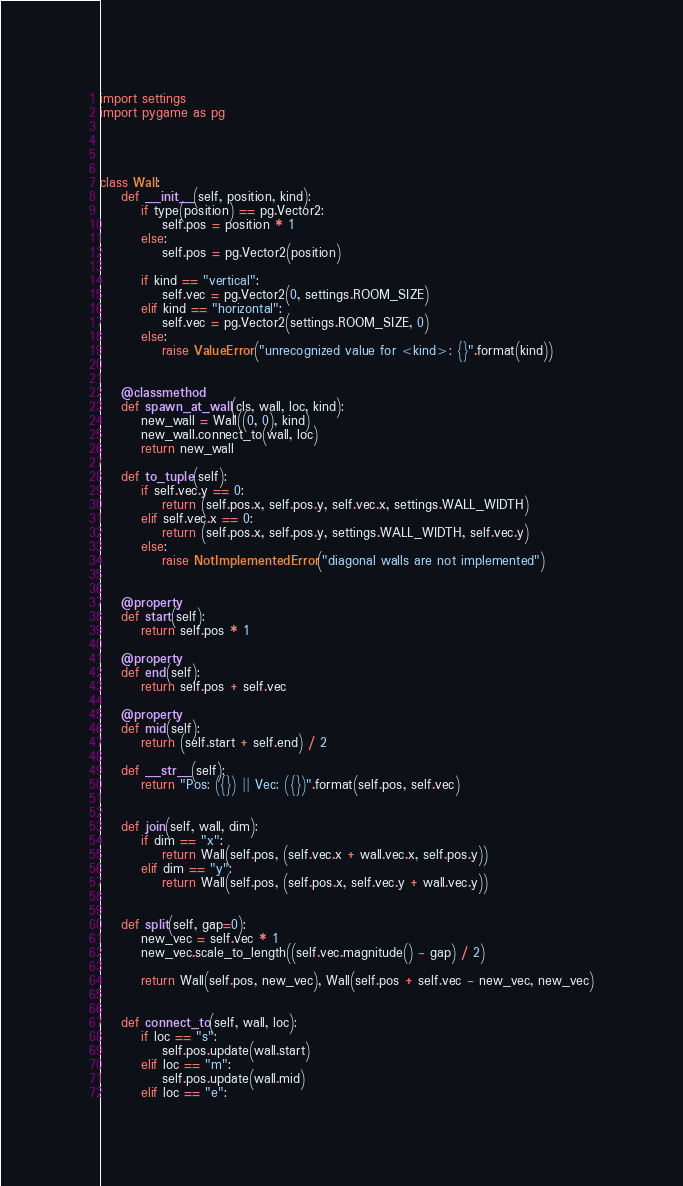Convert code to text. <code><loc_0><loc_0><loc_500><loc_500><_Python_>import settings
import pygame as pg




class Wall:
    def __init__(self, position, kind):
        if type(position) == pg.Vector2:
            self.pos = position * 1
        else:
            self.pos = pg.Vector2(position)

        if kind == "vertical":
            self.vec = pg.Vector2(0, settings.ROOM_SIZE)
        elif kind == "horizontal":
            self.vec = pg.Vector2(settings.ROOM_SIZE, 0)
        else:
            raise ValueError("unrecognized value for <kind>: {}".format(kind))


    @classmethod
    def spawn_at_wall(cls, wall, loc, kind):
        new_wall = Wall((0, 0), kind)
        new_wall.connect_to(wall, loc)
        return new_wall

    def to_tuple(self):
        if self.vec.y == 0:
            return (self.pos.x, self.pos.y, self.vec.x, settings.WALL_WIDTH)
        elif self.vec.x == 0:
            return (self.pos.x, self.pos.y, settings.WALL_WIDTH, self.vec.y)
        else:
            raise NotImplementedError("diagonal walls are not implemented")


    @property
    def start(self):
        return self.pos * 1

    @property
    def end(self):
        return self.pos + self.vec

    @property
    def mid(self):
        return (self.start + self.end) / 2

    def __str__(self):
        return "Pos: ({}) || Vec: ({})".format(self.pos, self.vec)


    def join(self, wall, dim):
        if dim == "x":
            return Wall(self.pos, (self.vec.x + wall.vec.x, self.pos.y))
        elif dim == "y":
            return Wall(self.pos, (self.pos.x, self.vec.y + wall.vec.y))


    def split(self, gap=0):
        new_vec = self.vec * 1
        new_vec.scale_to_length((self.vec.magnitude() - gap) / 2)

        return Wall(self.pos, new_vec), Wall(self.pos + self.vec - new_vec, new_vec)


    def connect_to(self, wall, loc):
        if loc == "s":
            self.pos.update(wall.start)
        elif loc == "m":
            self.pos.update(wall.mid)
        elif loc == "e":</code> 